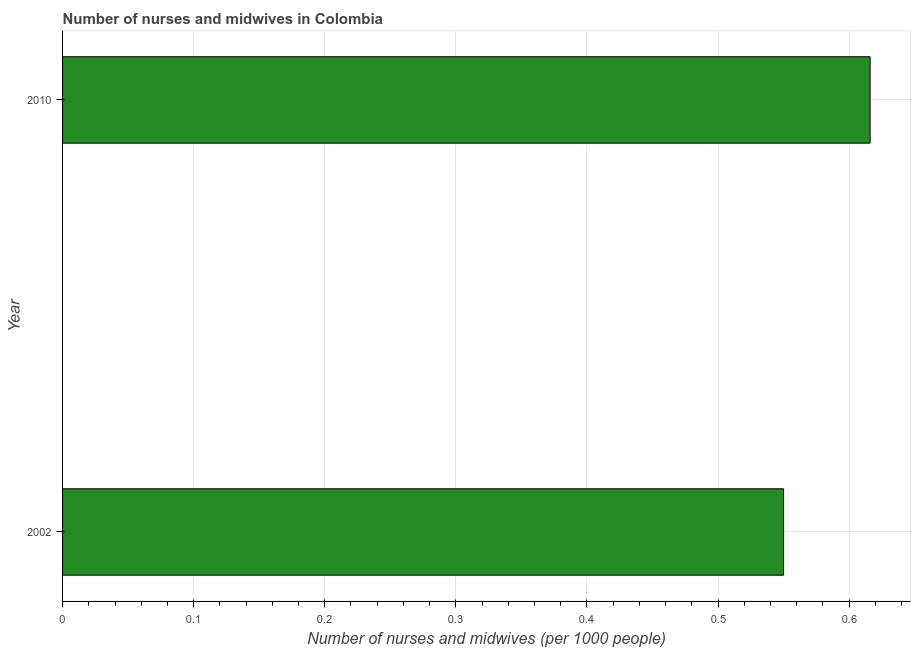Does the graph contain any zero values?
Provide a succinct answer. No. What is the title of the graph?
Offer a very short reply. Number of nurses and midwives in Colombia. What is the label or title of the X-axis?
Your answer should be compact. Number of nurses and midwives (per 1000 people). What is the number of nurses and midwives in 2002?
Provide a short and direct response. 0.55. Across all years, what is the maximum number of nurses and midwives?
Keep it short and to the point. 0.62. Across all years, what is the minimum number of nurses and midwives?
Provide a short and direct response. 0.55. What is the sum of the number of nurses and midwives?
Provide a succinct answer. 1.17. What is the difference between the number of nurses and midwives in 2002 and 2010?
Offer a terse response. -0.07. What is the average number of nurses and midwives per year?
Ensure brevity in your answer.  0.58. What is the median number of nurses and midwives?
Ensure brevity in your answer.  0.58. Do a majority of the years between 2002 and 2010 (inclusive) have number of nurses and midwives greater than 0.24 ?
Give a very brief answer. Yes. What is the ratio of the number of nurses and midwives in 2002 to that in 2010?
Ensure brevity in your answer.  0.89. In how many years, is the number of nurses and midwives greater than the average number of nurses and midwives taken over all years?
Offer a very short reply. 1. How many bars are there?
Make the answer very short. 2. Are all the bars in the graph horizontal?
Offer a very short reply. Yes. How many years are there in the graph?
Ensure brevity in your answer.  2. What is the difference between two consecutive major ticks on the X-axis?
Your answer should be compact. 0.1. Are the values on the major ticks of X-axis written in scientific E-notation?
Ensure brevity in your answer.  No. What is the Number of nurses and midwives (per 1000 people) in 2002?
Make the answer very short. 0.55. What is the Number of nurses and midwives (per 1000 people) of 2010?
Your response must be concise. 0.62. What is the difference between the Number of nurses and midwives (per 1000 people) in 2002 and 2010?
Offer a terse response. -0.07. What is the ratio of the Number of nurses and midwives (per 1000 people) in 2002 to that in 2010?
Offer a terse response. 0.89. 